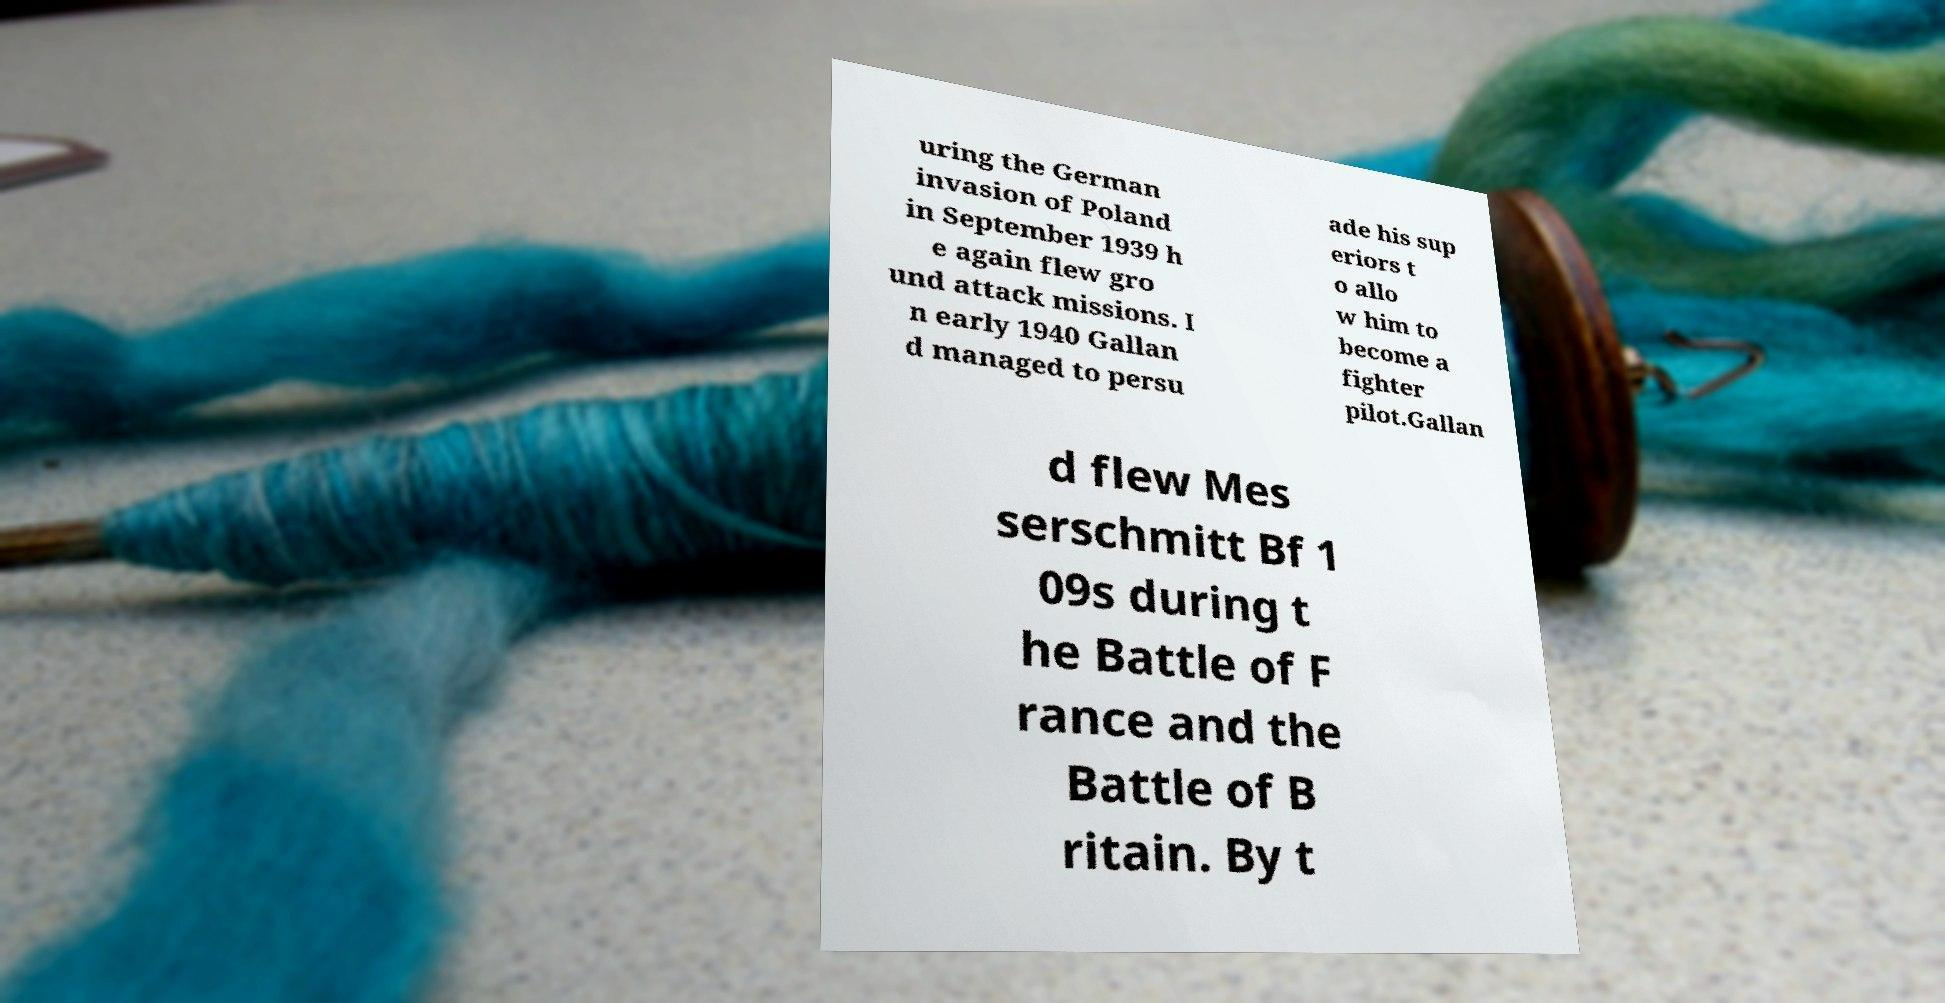Please read and relay the text visible in this image. What does it say? uring the German invasion of Poland in September 1939 h e again flew gro und attack missions. I n early 1940 Gallan d managed to persu ade his sup eriors t o allo w him to become a fighter pilot.Gallan d flew Mes serschmitt Bf 1 09s during t he Battle of F rance and the Battle of B ritain. By t 